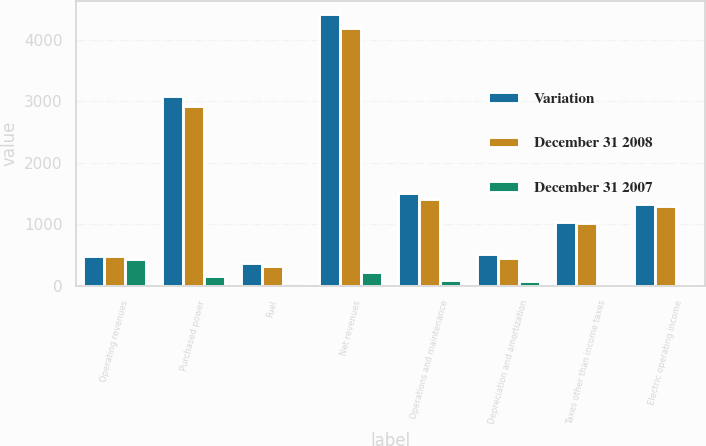Convert chart to OTSL. <chart><loc_0><loc_0><loc_500><loc_500><stacked_bar_chart><ecel><fcel>Operating revenues<fcel>Purchased power<fcel>Fuel<fcel>Net revenues<fcel>Operations and maintenance<fcel>Depreciation and amortization<fcel>Taxes other than income taxes<fcel>Electric operating income<nl><fcel>Variation<fcel>484.5<fcel>3092<fcel>376<fcel>4410<fcel>1518<fcel>521<fcel>1038<fcel>1333<nl><fcel>December 31 2008<fcel>484.5<fcel>2929<fcel>324<fcel>4187<fcel>1416<fcel>448<fcel>1019<fcel>1304<nl><fcel>December 31 2007<fcel>438<fcel>163<fcel>52<fcel>223<fcel>102<fcel>73<fcel>19<fcel>29<nl></chart> 